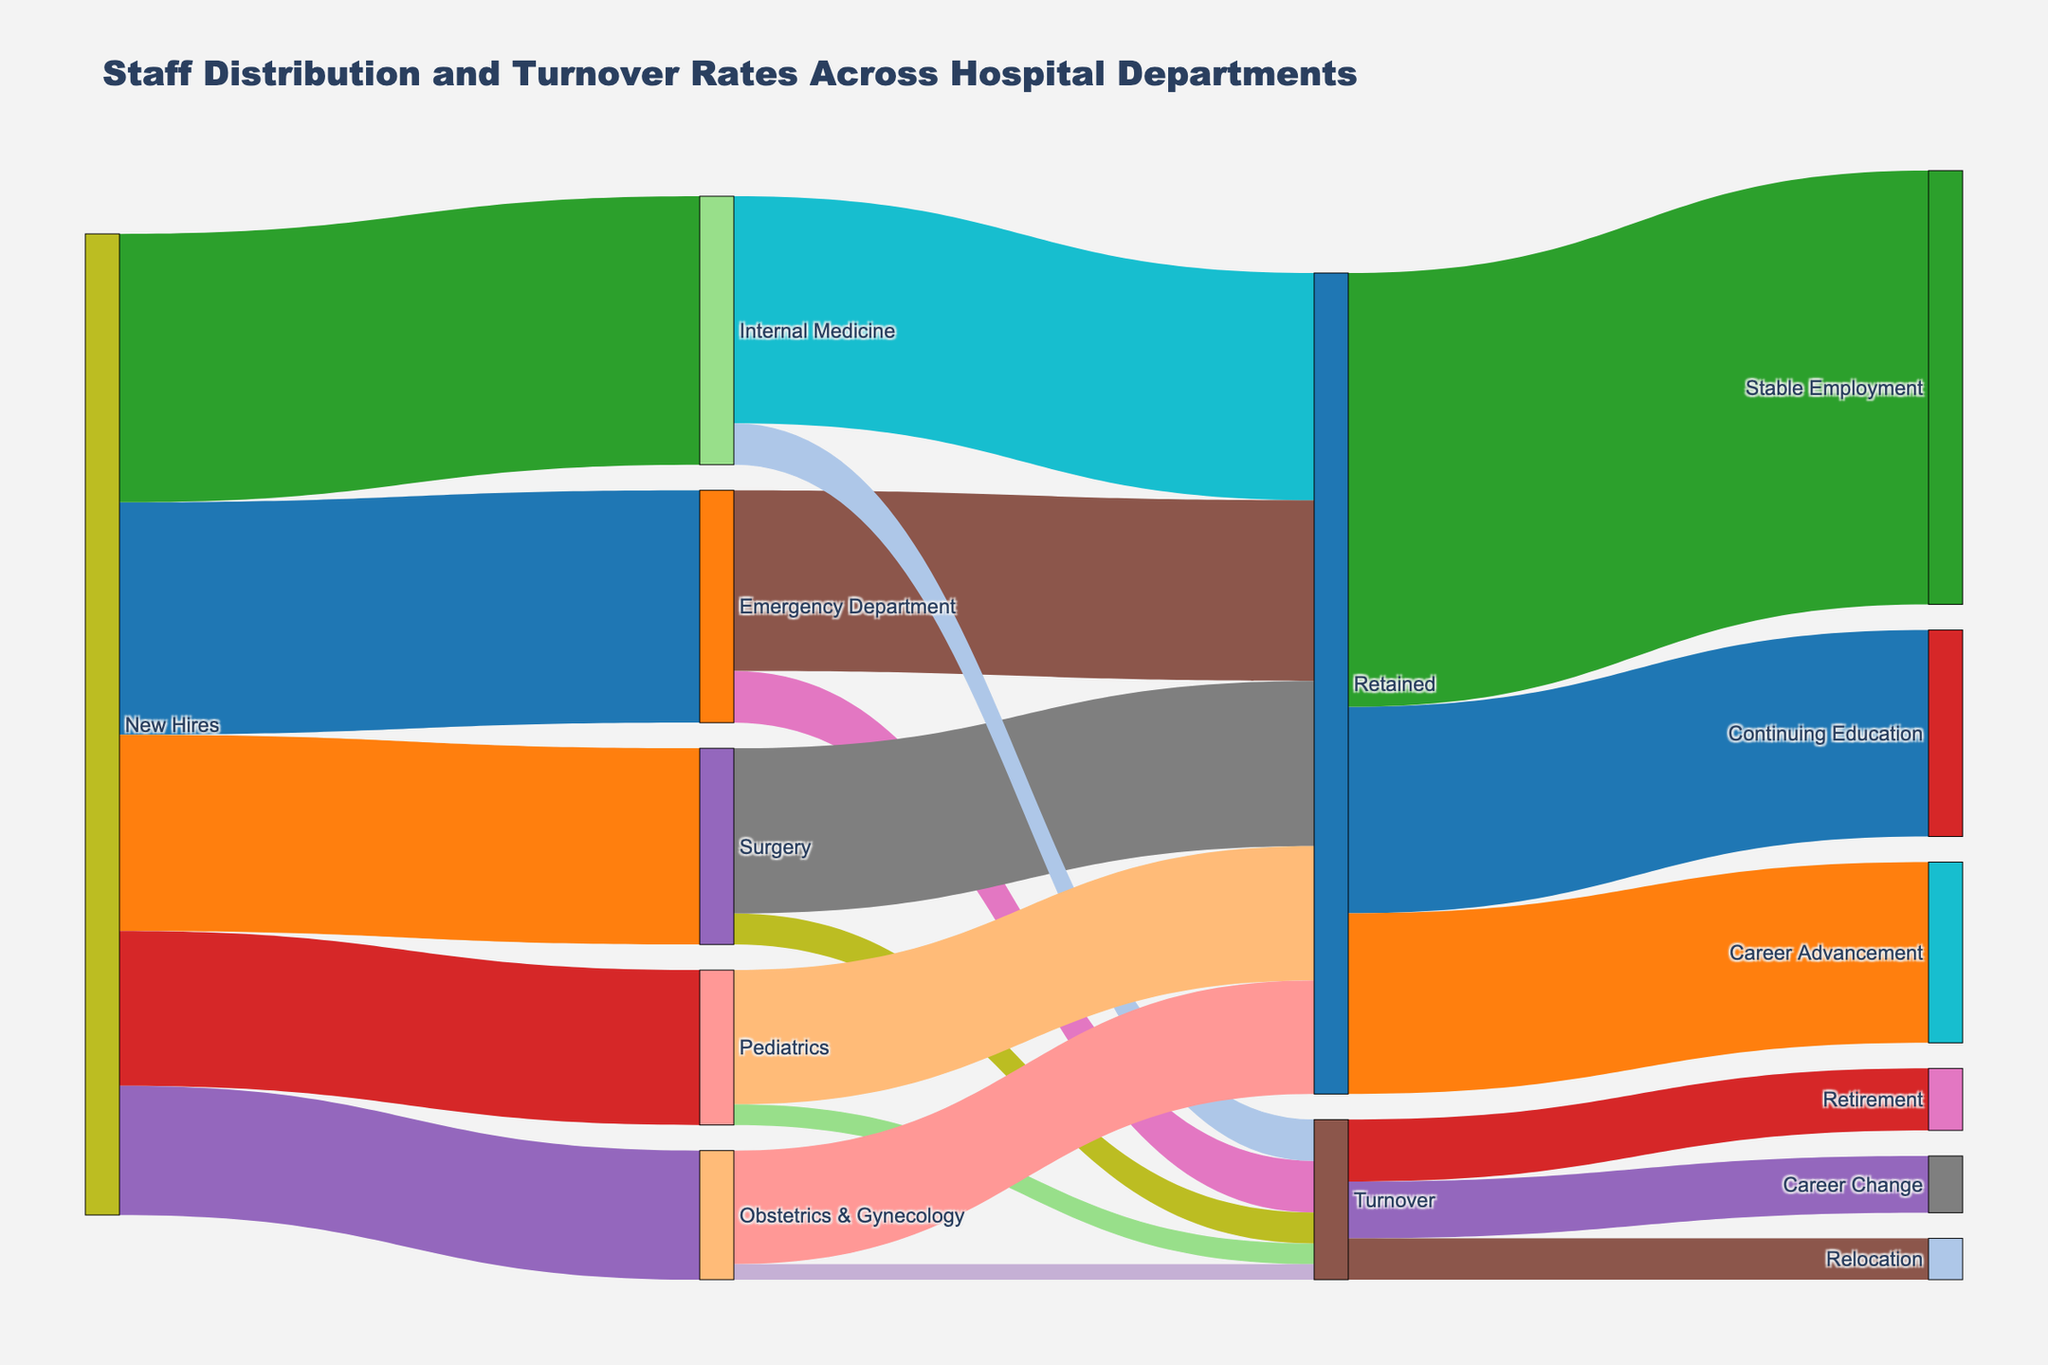How many new hires were there in total? The Sankey diagram shows the number of new hires in various departments. To find the total, sum up the values from each department: Emergency Department (45), Surgery (38), Internal Medicine (52), Pediatrics (30), Obstetrics & Gynecology (25). 45 + 38 + 52 + 30 + 25 = 190.
Answer: 190 Which department had the highest number of new hires? Compare the values of new hires across the departments: Emergency Department (45), Surgery (38), Internal Medicine (52), Pediatrics (30), Obstetrics & Gynecology (25). The highest number is for Internal Medicine (52).
Answer: Internal Medicine How many staff were retained in the Internal Medicine department? The diagram shows the flow from Internal Medicine to Retained and Turnover. The value for Retained in Internal Medicine is 44.
Answer: 44 What is the total turnover across all departments? Sum the turnover values from each department: Emergency Department (10), Surgery (6), Internal Medicine (8), Pediatrics (4), Obstetrics & Gynecology (3). 10 + 6 + 8 + 4 + 3 = 31.
Answer: 31 How many staff from the Retained group went on to Stable Employment? The flow from Retained to Stable Employment is clearly marked, showing a value of 84.
Answer: 84 What percentage of the new hires were retained in the Surgery department? To find the percentage, first identify the number of new hires in Surgery (38) and those retained in Surgery (32). Then, calculate the percentage: (32 / 38) * 100 ≈ 84.21%.
Answer: 84.21% Which reason had the least number of turnovers? The diagram shows the turnover reasons: Retirement (12), Career Change (11), and Relocation (8). The least is Relocation.
Answer: Relocation Compare the values for staff in Continuing Education and Career Advancement. Which is higher? The values for Continuing Education and Career Advancement are shown as 40 and 35, respectively. Continuing Education is higher.
Answer: Continuing Education 